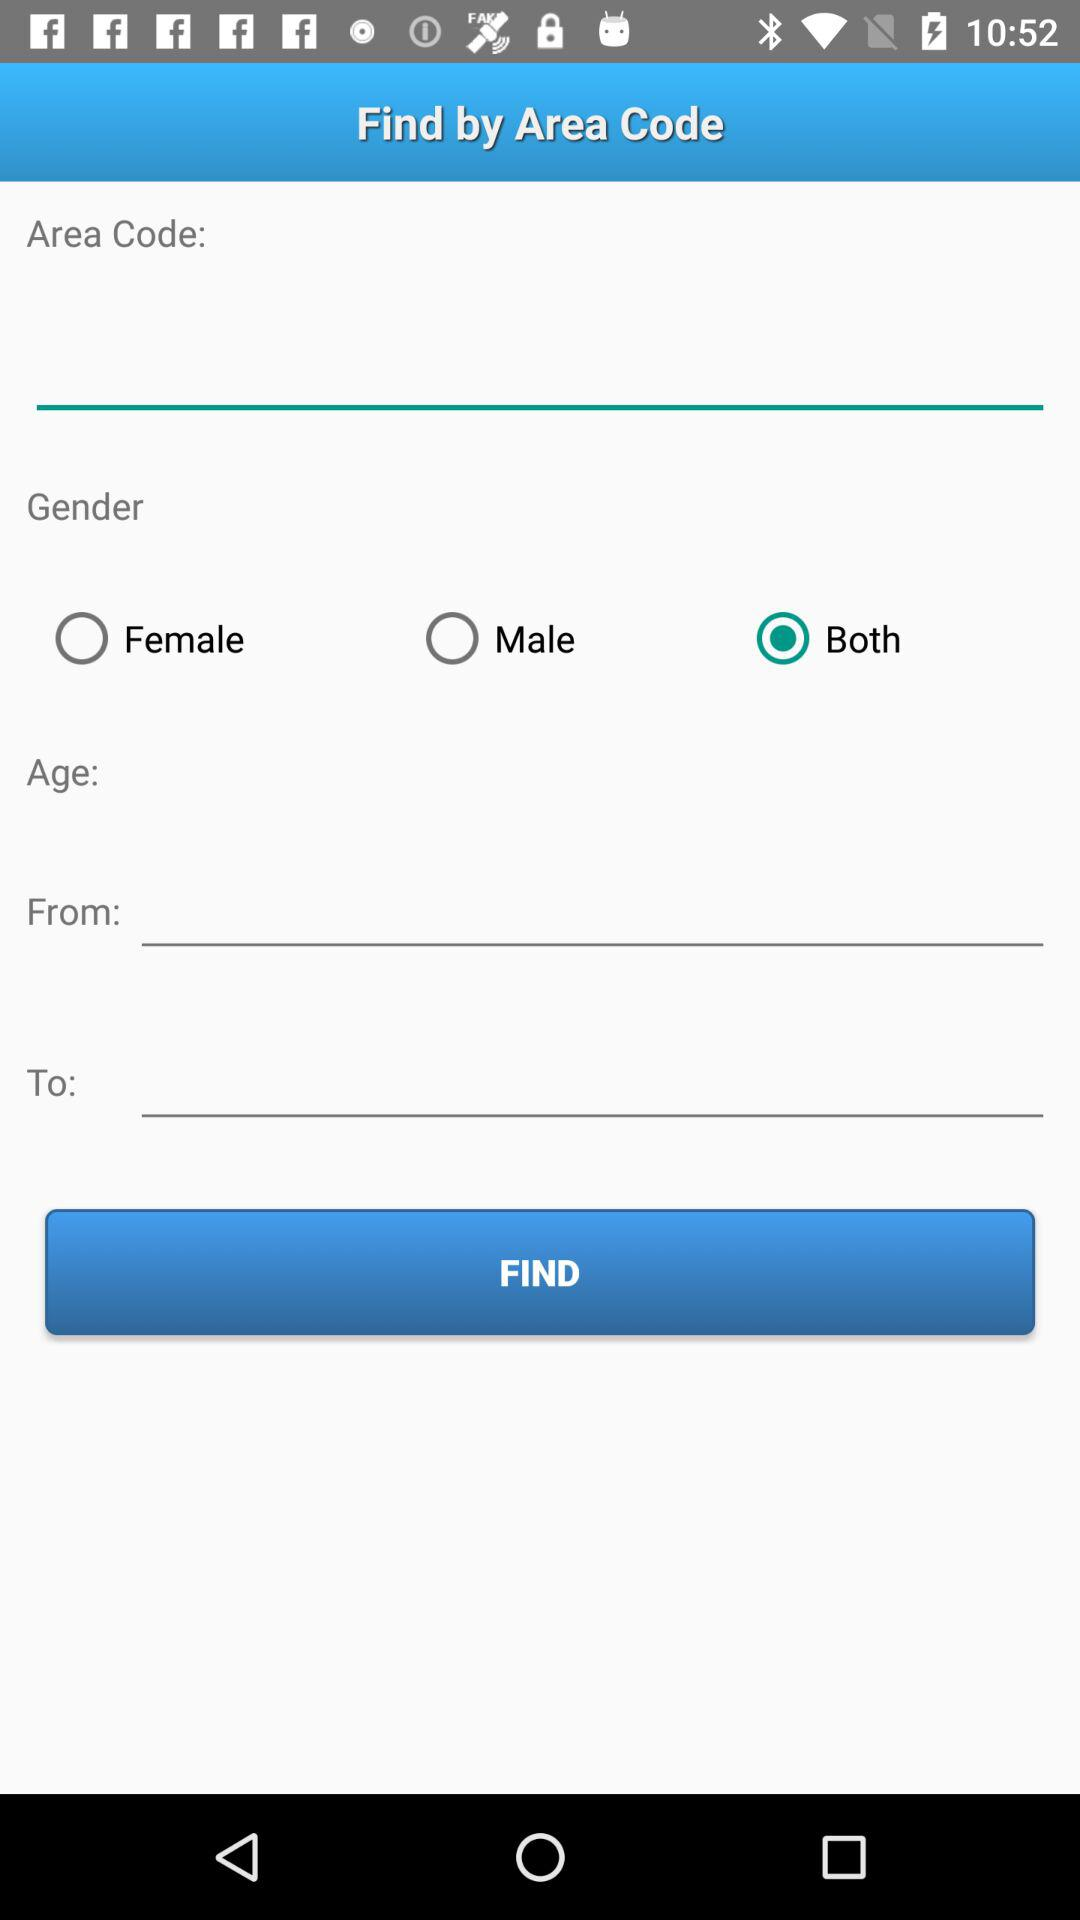How many text inputs are there for the age range?
Answer the question using a single word or phrase. 2 